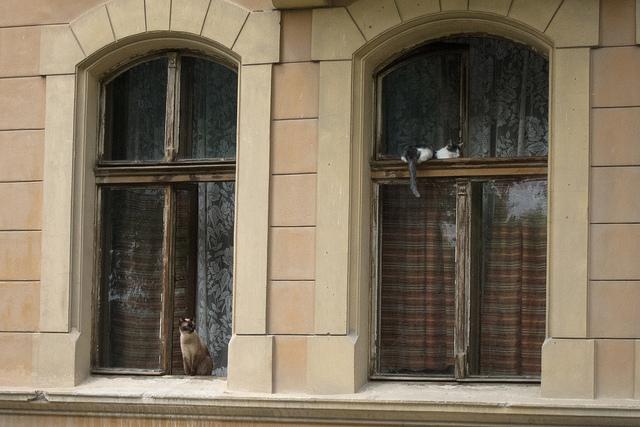Is the cat an indoor cat or an outdoor cat?
Answer briefly. Indoor. How many windows are shown?
Give a very brief answer. 2. How many plates of glass are depicted?
Quick response, please. 8. Is there glass?
Write a very short answer. Yes. 